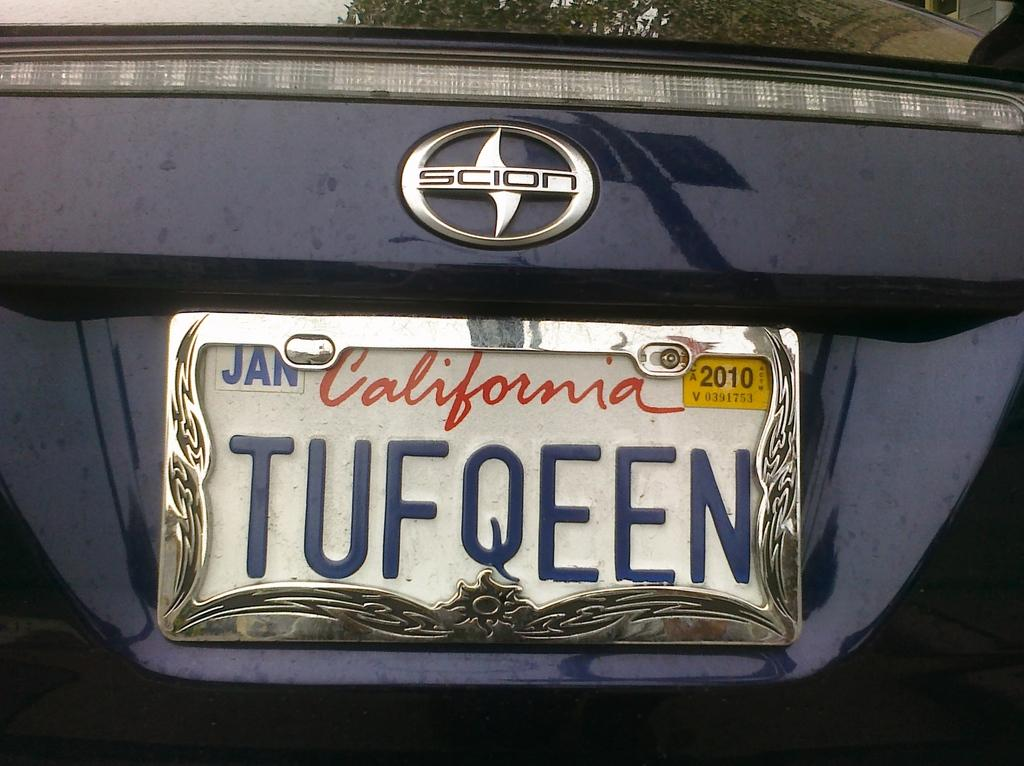<image>
Describe the image concisely. A California license plate on a Scion expires in 2010. 